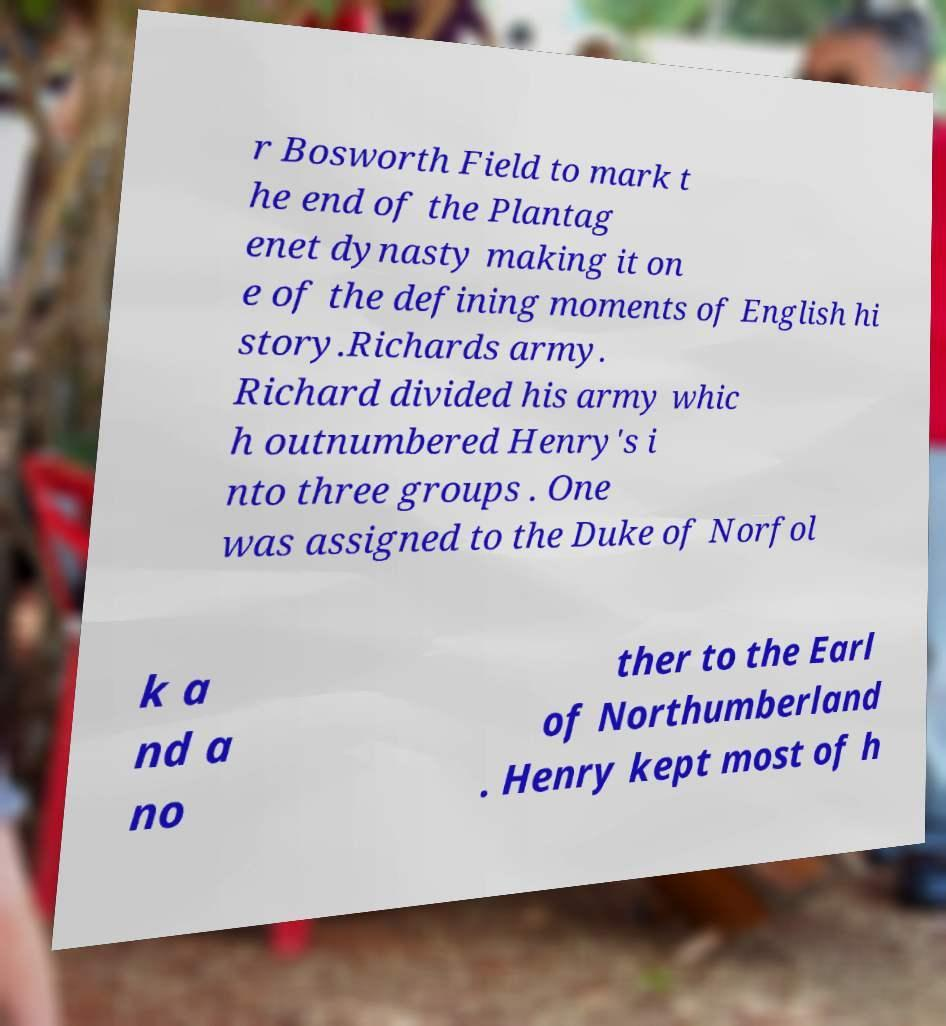Could you assist in decoding the text presented in this image and type it out clearly? r Bosworth Field to mark t he end of the Plantag enet dynasty making it on e of the defining moments of English hi story.Richards army. Richard divided his army whic h outnumbered Henry's i nto three groups . One was assigned to the Duke of Norfol k a nd a no ther to the Earl of Northumberland . Henry kept most of h 